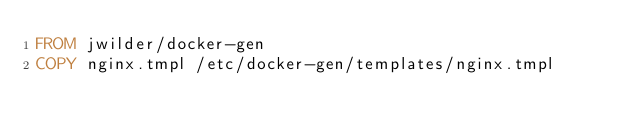<code> <loc_0><loc_0><loc_500><loc_500><_Dockerfile_>FROM jwilder/docker-gen
COPY nginx.tmpl /etc/docker-gen/templates/nginx.tmpl
</code> 